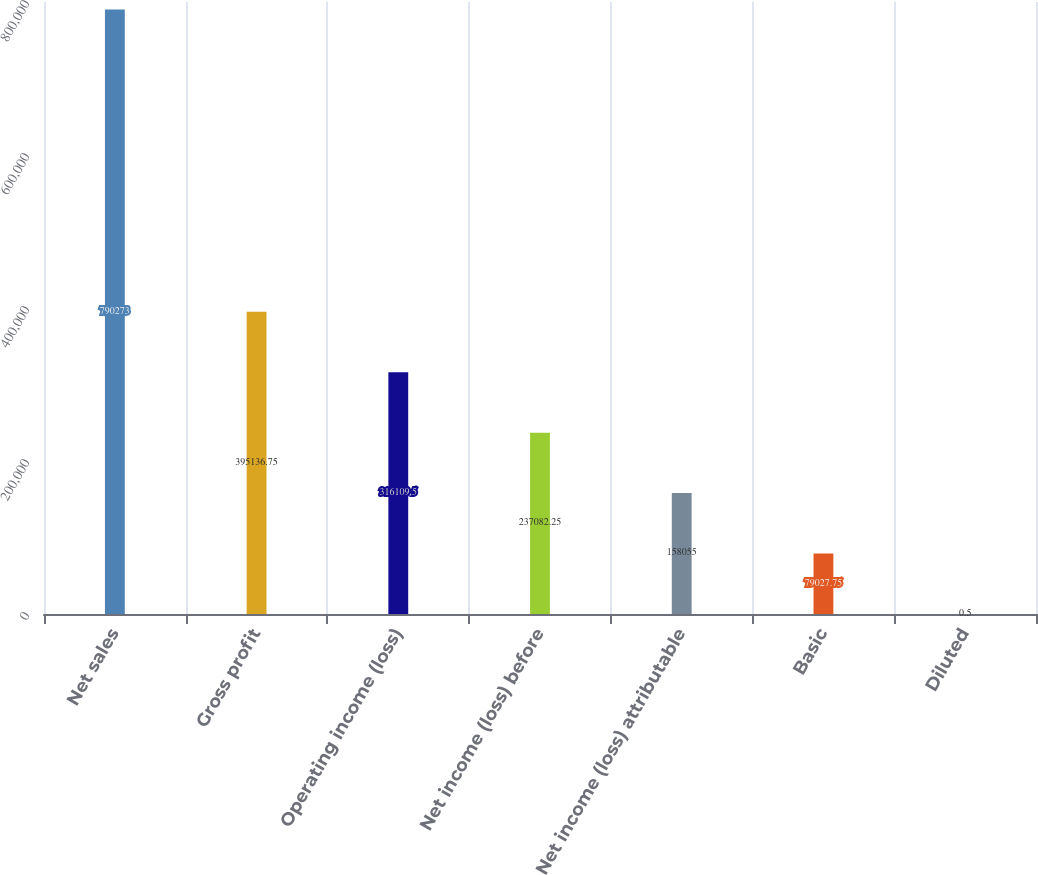Convert chart. <chart><loc_0><loc_0><loc_500><loc_500><bar_chart><fcel>Net sales<fcel>Gross profit<fcel>Operating income (loss)<fcel>Net income (loss) before<fcel>Net income (loss) attributable<fcel>Basic<fcel>Diluted<nl><fcel>790273<fcel>395137<fcel>316110<fcel>237082<fcel>158055<fcel>79027.8<fcel>0.5<nl></chart> 